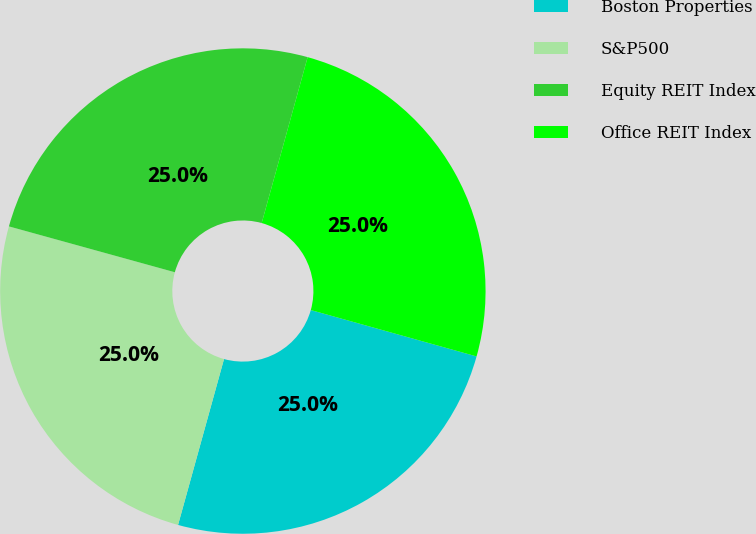Convert chart. <chart><loc_0><loc_0><loc_500><loc_500><pie_chart><fcel>Boston Properties<fcel>S&P500<fcel>Equity REIT Index<fcel>Office REIT Index<nl><fcel>24.96%<fcel>24.99%<fcel>25.01%<fcel>25.04%<nl></chart> 